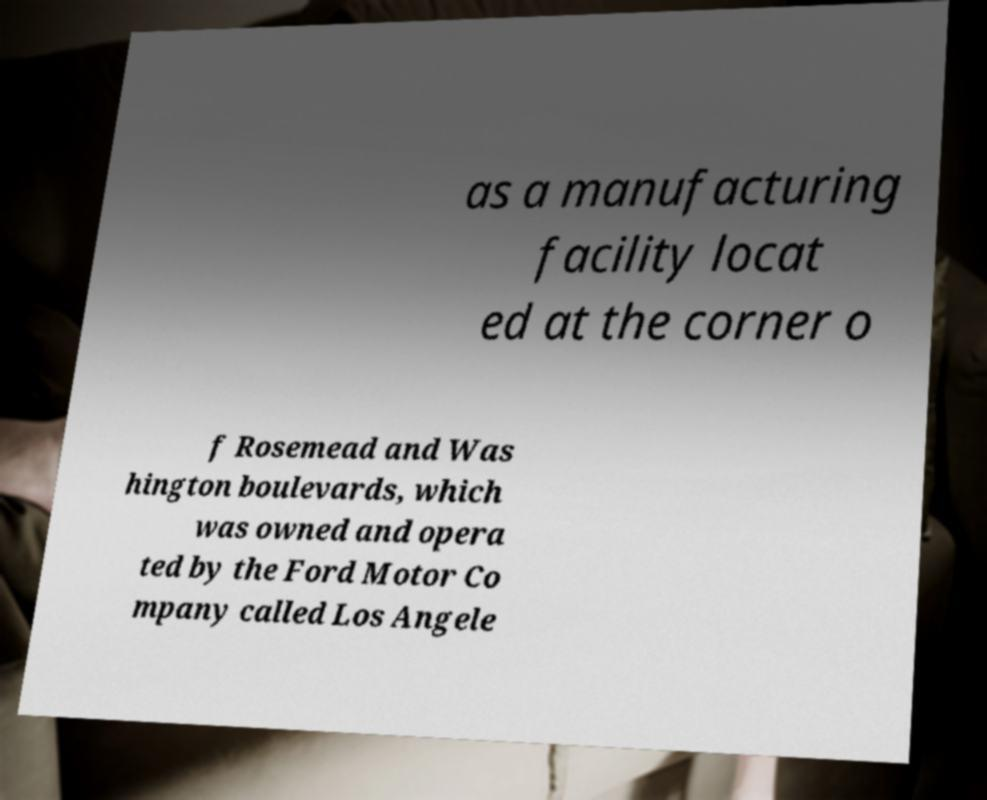Could you assist in decoding the text presented in this image and type it out clearly? as a manufacturing facility locat ed at the corner o f Rosemead and Was hington boulevards, which was owned and opera ted by the Ford Motor Co mpany called Los Angele 